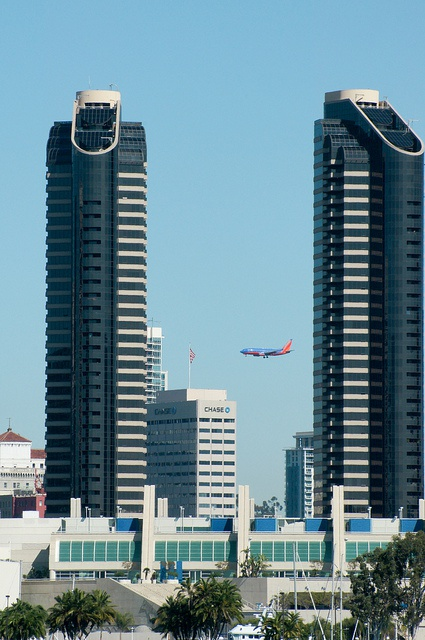Describe the objects in this image and their specific colors. I can see a airplane in lightblue, salmon, and gray tones in this image. 